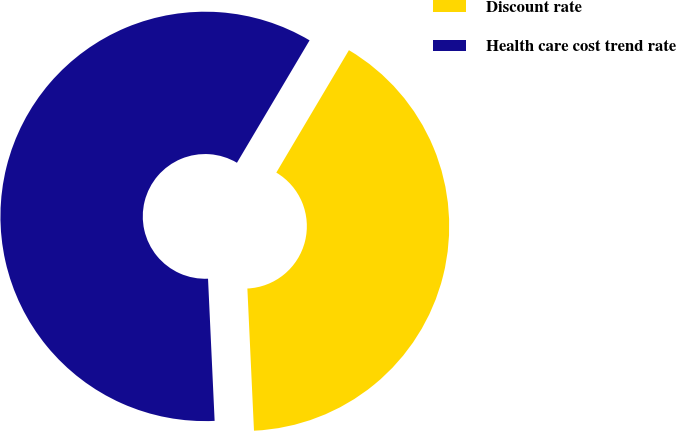Convert chart. <chart><loc_0><loc_0><loc_500><loc_500><pie_chart><fcel>Discount rate<fcel>Health care cost trend rate<nl><fcel>40.74%<fcel>59.26%<nl></chart> 